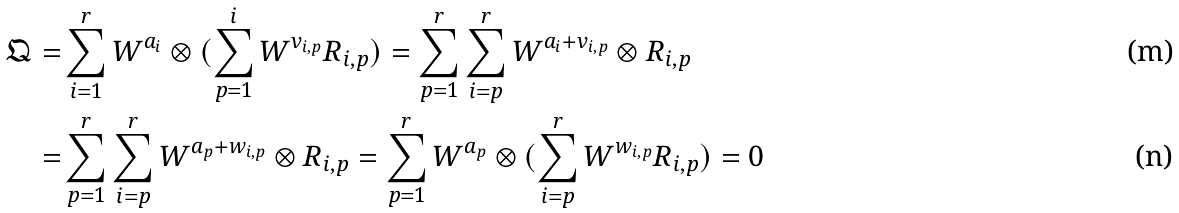Convert formula to latex. <formula><loc_0><loc_0><loc_500><loc_500>\mathfrak { Q } = & \sum _ { i = 1 } ^ { r } W ^ { a _ { i } } \otimes ( \sum _ { p = 1 } ^ { i } W ^ { v _ { i , p } } R _ { i , p } ) = \sum _ { p = 1 } ^ { r } \sum _ { i = p } ^ { r } W ^ { a _ { i } + v _ { i , p } } \otimes R _ { i , p } \\ = & \sum _ { p = 1 } ^ { r } \sum _ { i = p } ^ { r } W ^ { a _ { p } + w _ { i , p } } \otimes R _ { i , p } = \sum _ { p = 1 } ^ { r } W ^ { a _ { p } } \otimes ( \sum _ { i = p } ^ { r } W ^ { w _ { i , p } } R _ { i , p } ) = 0</formula> 